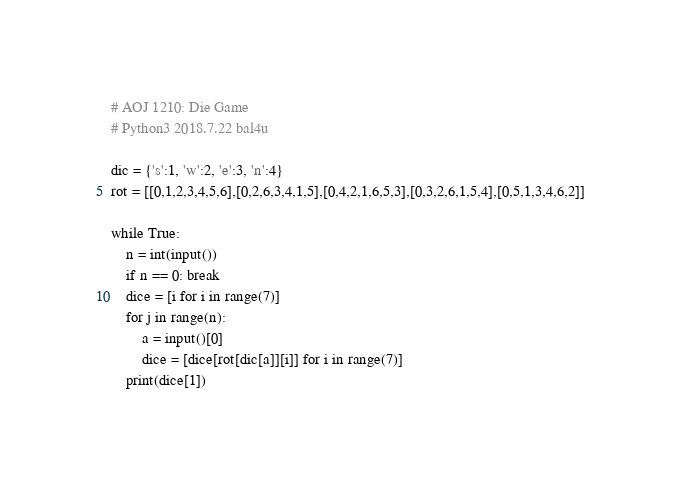Convert code to text. <code><loc_0><loc_0><loc_500><loc_500><_Python_># AOJ 1210: Die Game
# Python3 2018.7.22 bal4u

dic = {'s':1, 'w':2, 'e':3, 'n':4}
rot = [[0,1,2,3,4,5,6],[0,2,6,3,4,1,5],[0,4,2,1,6,5,3],[0,3,2,6,1,5,4],[0,5,1,3,4,6,2]]
	
while True:
    n = int(input())
    if n == 0: break
    dice = [i for i in range(7)]
    for j in range(n):
        a = input()[0]
        dice = [dice[rot[dic[a]][i]] for i in range(7)]
    print(dice[1])
</code> 